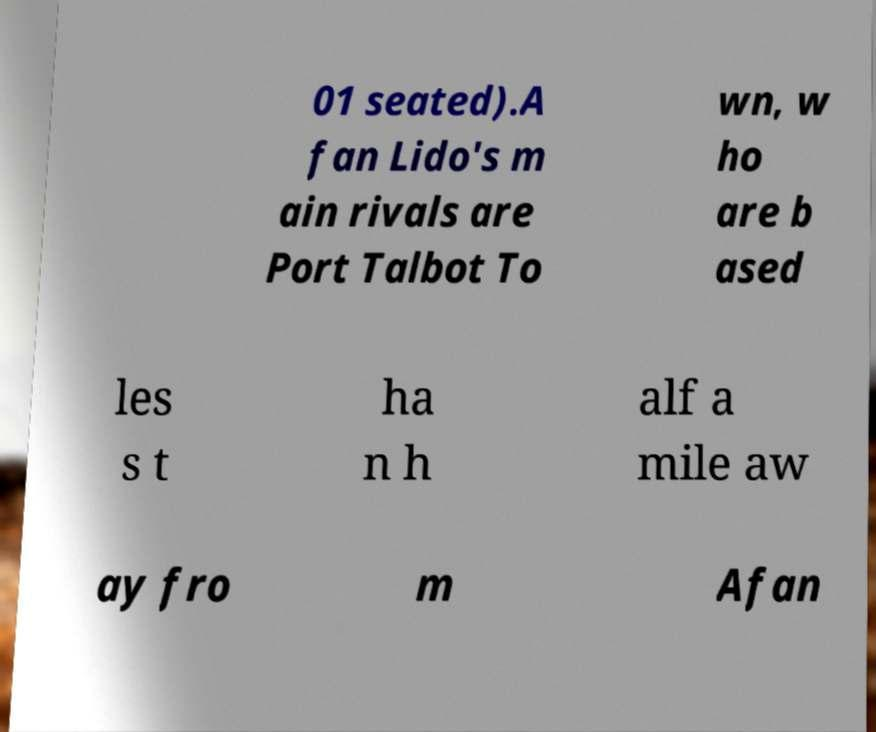There's text embedded in this image that I need extracted. Can you transcribe it verbatim? 01 seated).A fan Lido's m ain rivals are Port Talbot To wn, w ho are b ased les s t ha n h alf a mile aw ay fro m Afan 